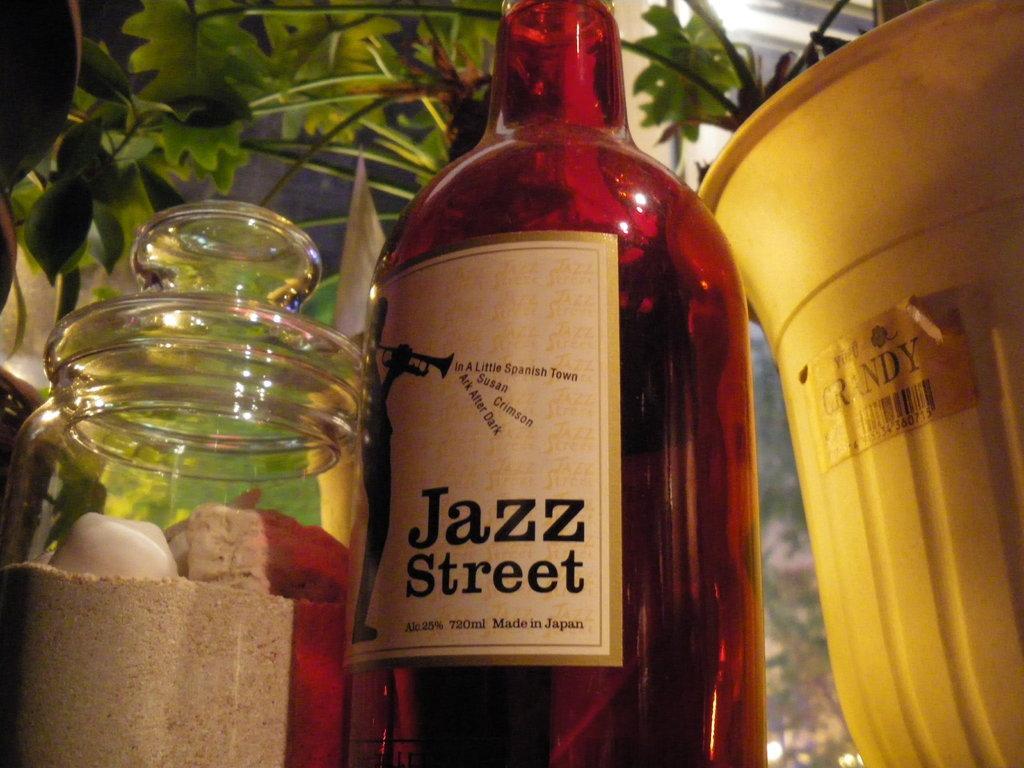Could you give a brief overview of what you see in this image? In this image I can see the bottle, glass jar, yellow color object and few plants around. 